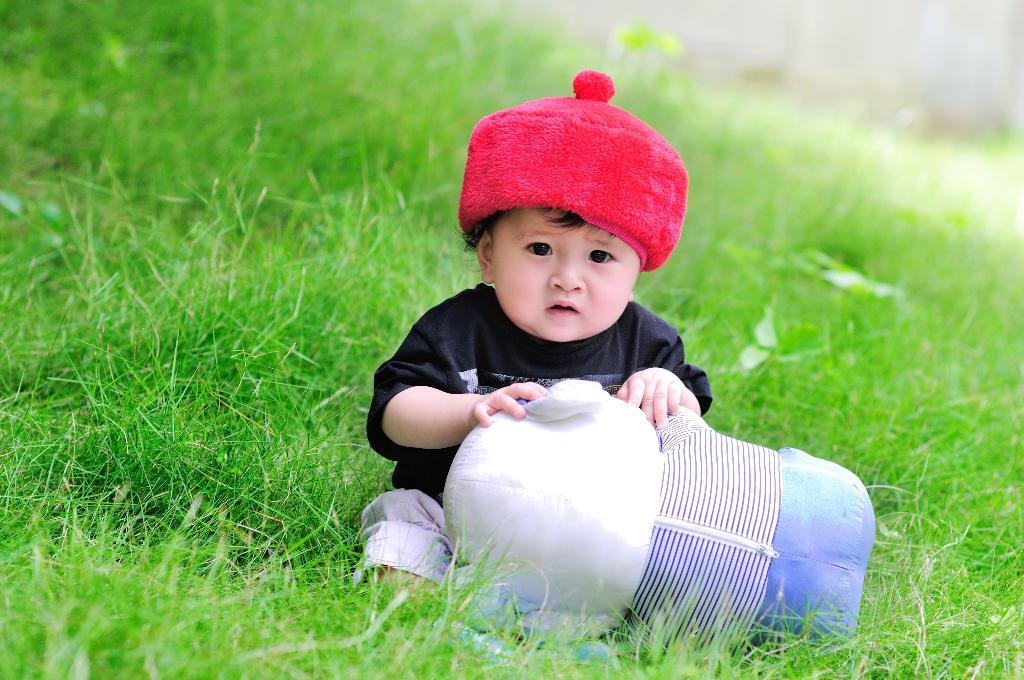Who is the main subject in the image? There is a little boy in the middle of the image. What is the little boy holding? The boy is holding a doll. What type of surface is visible in the image? There is grass visible in the image. What is the tax rate for the garden in the image? There is no mention of a garden or tax rate in the image, so it cannot be determined. 